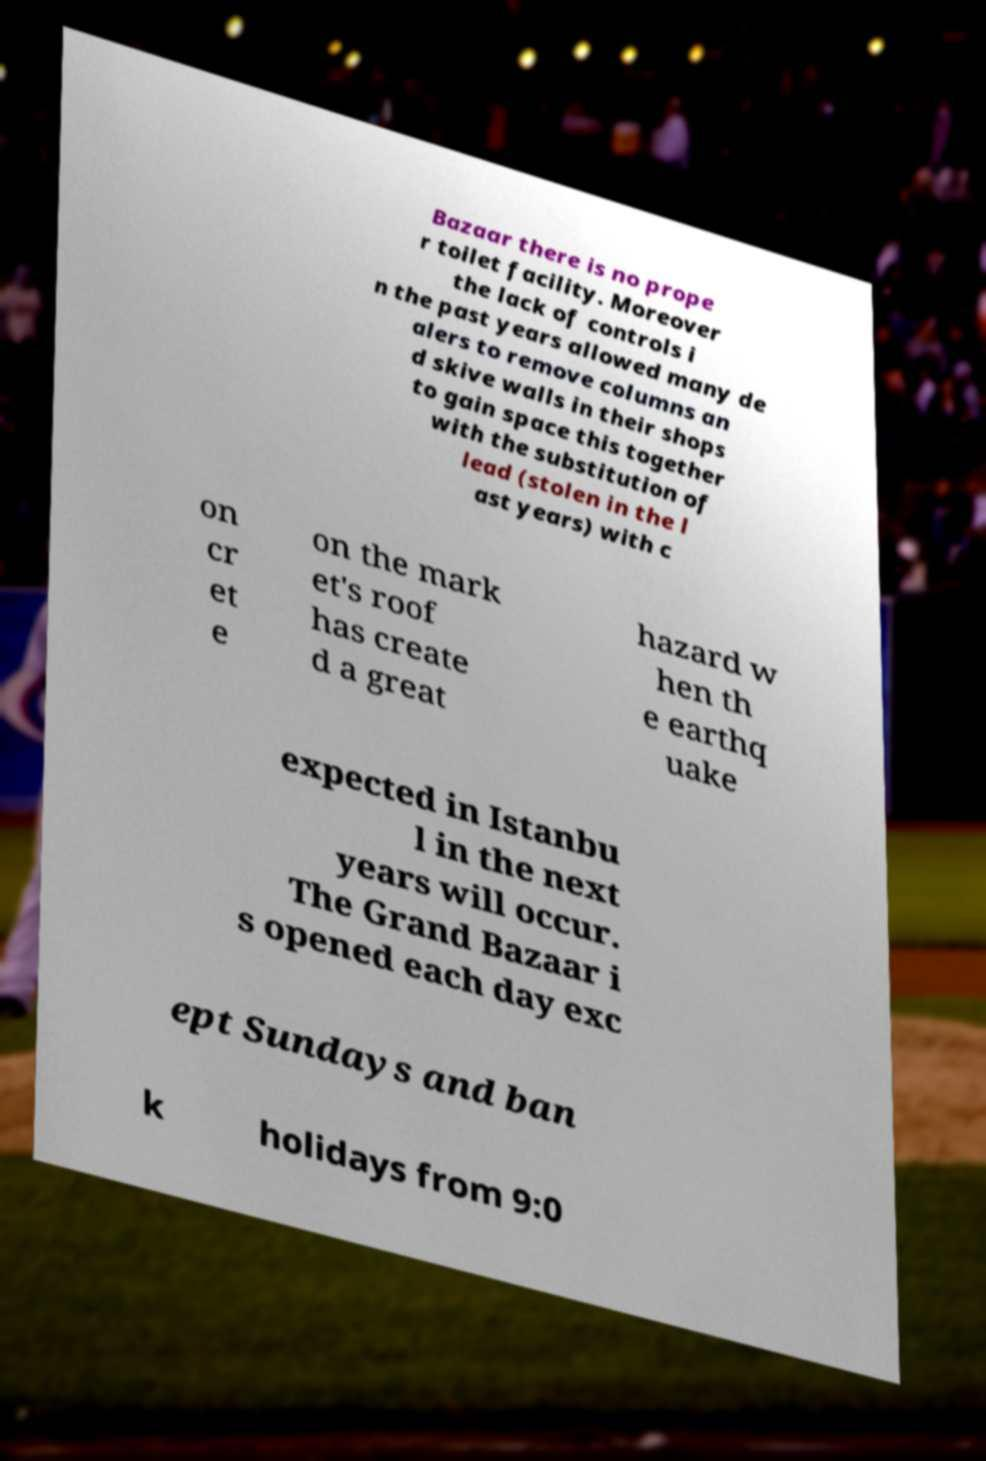Could you extract and type out the text from this image? Bazaar there is no prope r toilet facility. Moreover the lack of controls i n the past years allowed many de alers to remove columns an d skive walls in their shops to gain space this together with the substitution of lead (stolen in the l ast years) with c on cr et e on the mark et's roof has create d a great hazard w hen th e earthq uake expected in Istanbu l in the next years will occur. The Grand Bazaar i s opened each day exc ept Sundays and ban k holidays from 9:0 